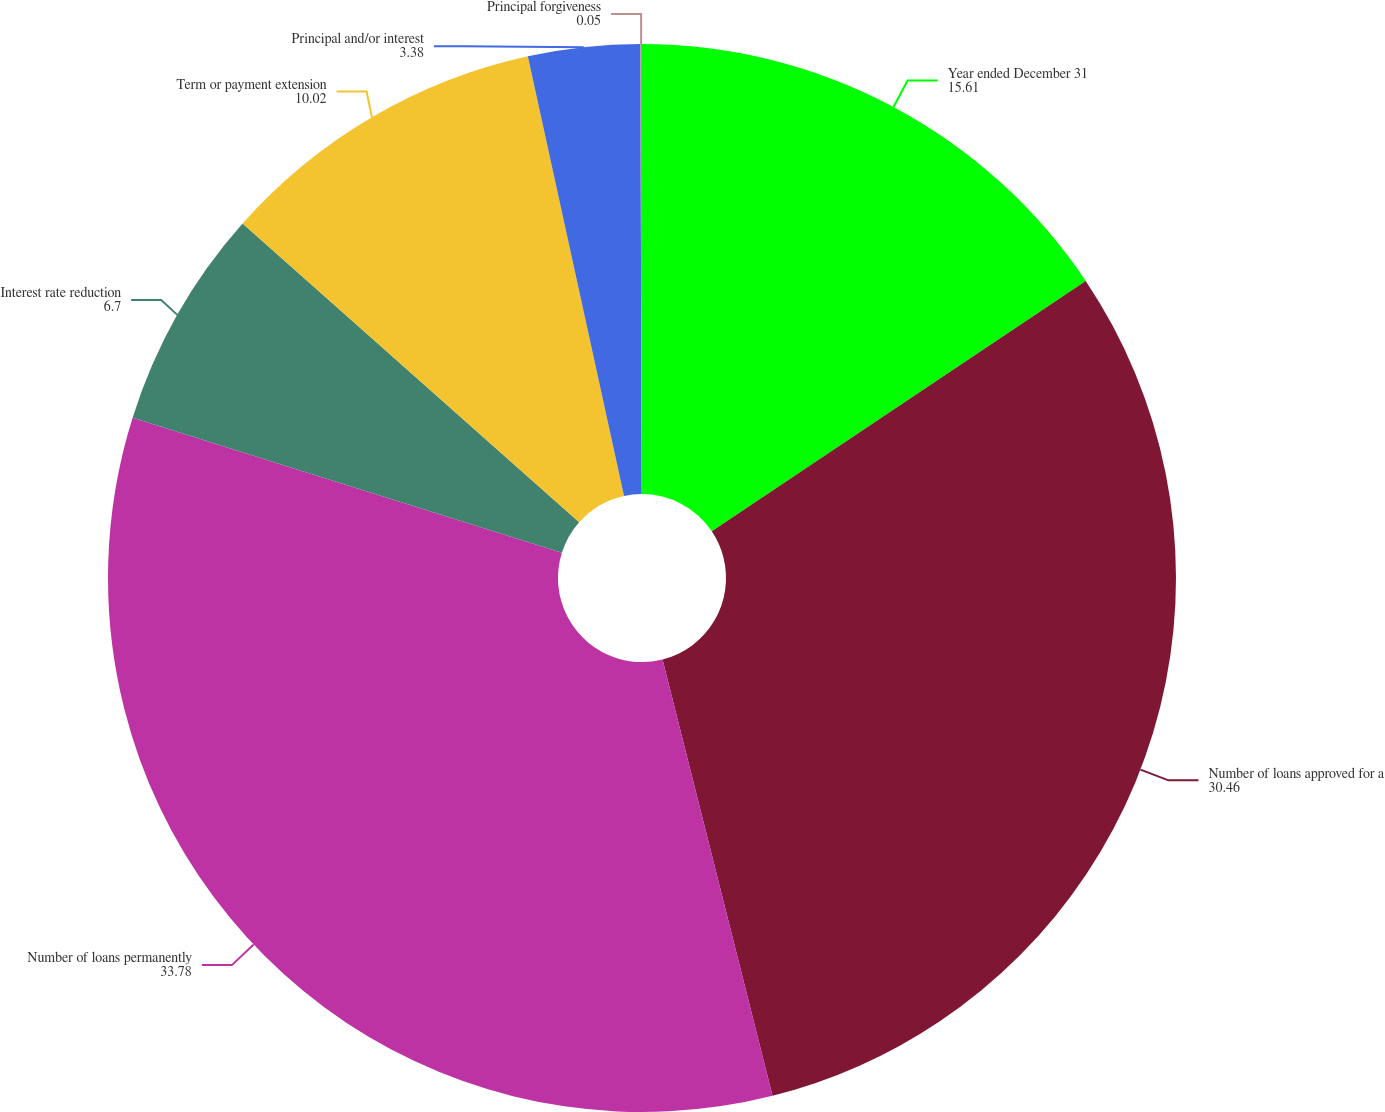Convert chart to OTSL. <chart><loc_0><loc_0><loc_500><loc_500><pie_chart><fcel>Year ended December 31<fcel>Number of loans approved for a<fcel>Number of loans permanently<fcel>Interest rate reduction<fcel>Term or payment extension<fcel>Principal and/or interest<fcel>Principal forgiveness<nl><fcel>15.61%<fcel>30.46%<fcel>33.78%<fcel>6.7%<fcel>10.02%<fcel>3.38%<fcel>0.05%<nl></chart> 